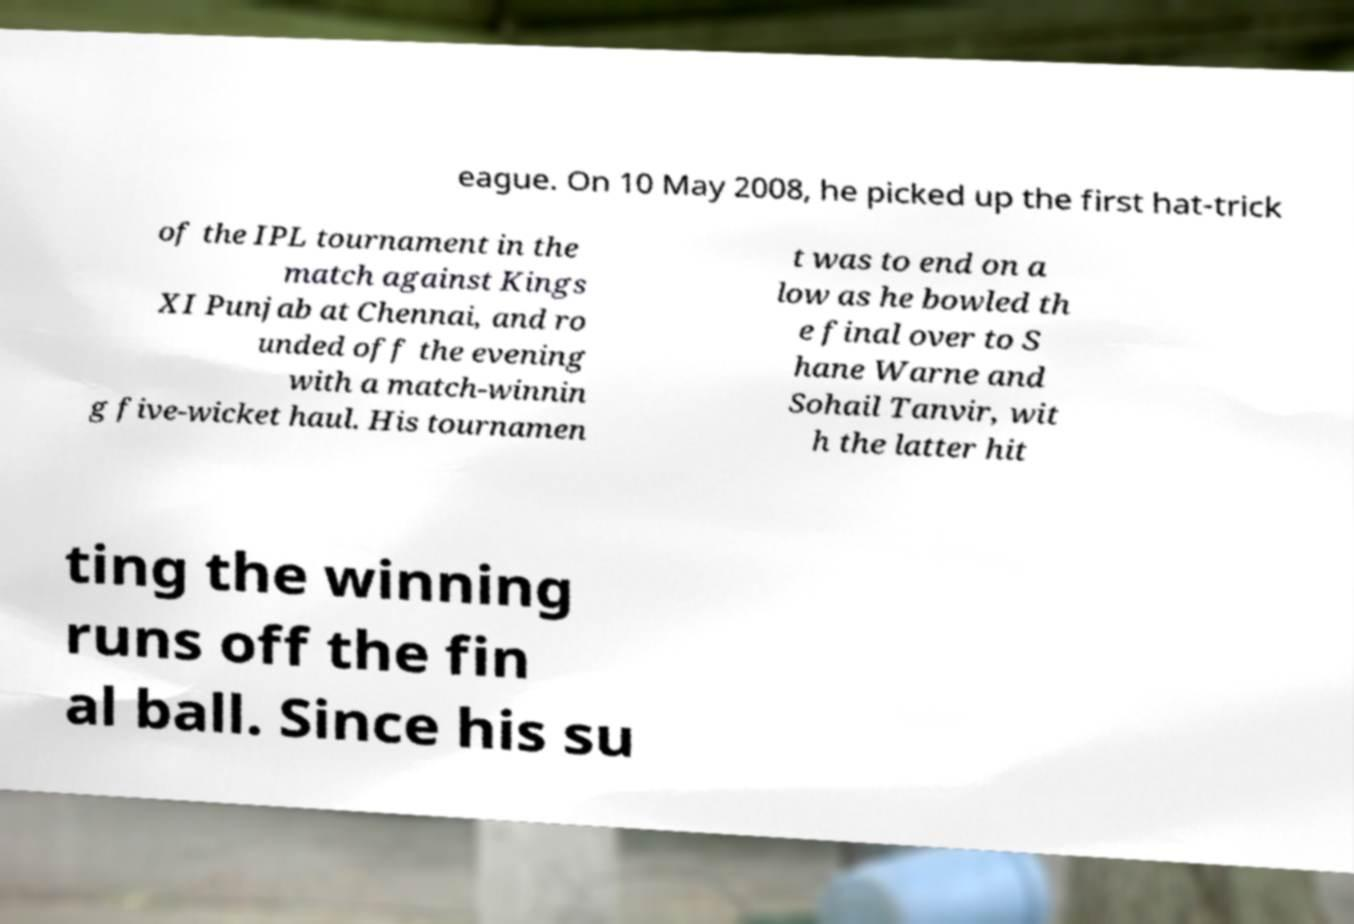Could you assist in decoding the text presented in this image and type it out clearly? eague. On 10 May 2008, he picked up the first hat-trick of the IPL tournament in the match against Kings XI Punjab at Chennai, and ro unded off the evening with a match-winnin g five-wicket haul. His tournamen t was to end on a low as he bowled th e final over to S hane Warne and Sohail Tanvir, wit h the latter hit ting the winning runs off the fin al ball. Since his su 